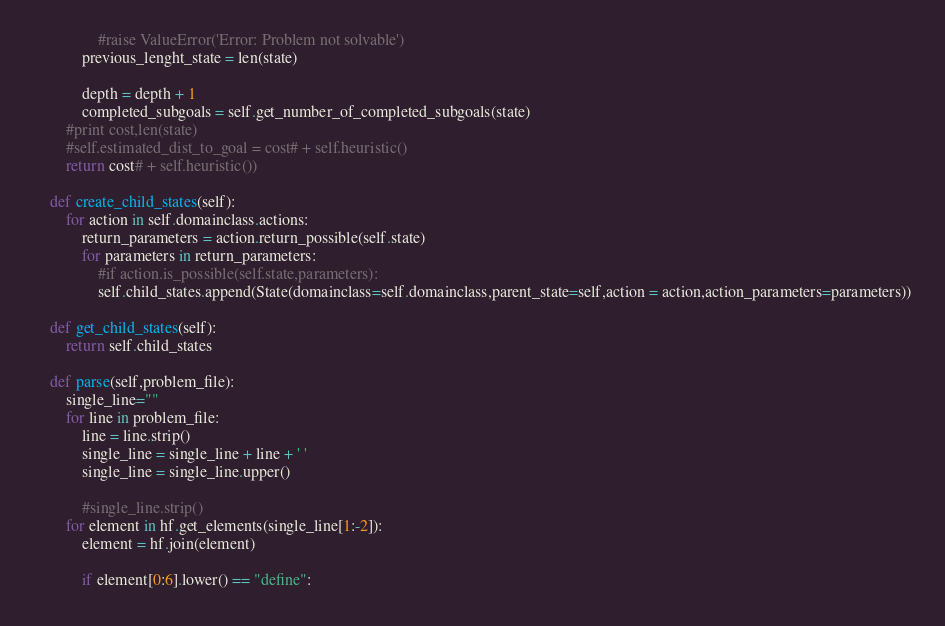Convert code to text. <code><loc_0><loc_0><loc_500><loc_500><_Python_>
				#raise ValueError('Error: Problem not solvable')
			previous_lenght_state = len(state)

			depth = depth + 1
			completed_subgoals = self.get_number_of_completed_subgoals(state)
		#print cost,len(state)
		#self.estimated_dist_to_goal = cost# + self.heuristic()
		return cost# + self.heuristic())

	def create_child_states(self):
		for action in self.domainclass.actions:
			return_parameters = action.return_possible(self.state)
			for parameters in return_parameters:
				#if action.is_possible(self.state,parameters):
				self.child_states.append(State(domainclass=self.domainclass,parent_state=self,action = action,action_parameters=parameters))

	def get_child_states(self):
		return self.child_states

	def parse(self,problem_file):
		single_line=""
		for line in problem_file:
			line = line.strip()
			single_line = single_line + line + ' '
			single_line = single_line.upper()

			#single_line.strip()
		for element in hf.get_elements(single_line[1:-2]):
			element = hf.join(element)

			if element[0:6].lower() == "define":</code> 